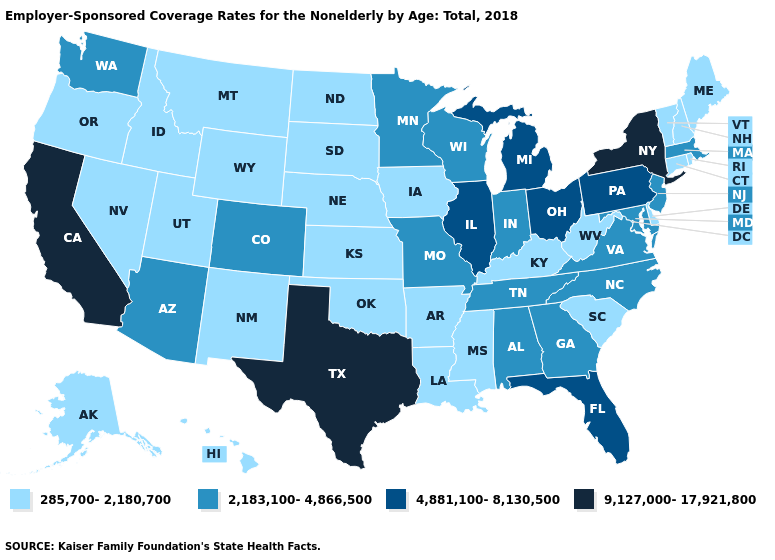Name the states that have a value in the range 4,881,100-8,130,500?
Short answer required. Florida, Illinois, Michigan, Ohio, Pennsylvania. What is the value of Vermont?
Short answer required. 285,700-2,180,700. Does West Virginia have the lowest value in the South?
Quick response, please. Yes. Does the first symbol in the legend represent the smallest category?
Answer briefly. Yes. What is the value of Maryland?
Concise answer only. 2,183,100-4,866,500. What is the highest value in the Northeast ?
Answer briefly. 9,127,000-17,921,800. Name the states that have a value in the range 2,183,100-4,866,500?
Give a very brief answer. Alabama, Arizona, Colorado, Georgia, Indiana, Maryland, Massachusetts, Minnesota, Missouri, New Jersey, North Carolina, Tennessee, Virginia, Washington, Wisconsin. What is the value of New Mexico?
Keep it brief. 285,700-2,180,700. What is the value of Alaska?
Quick response, please. 285,700-2,180,700. What is the highest value in the USA?
Give a very brief answer. 9,127,000-17,921,800. Which states have the highest value in the USA?
Be succinct. California, New York, Texas. What is the lowest value in the USA?
Concise answer only. 285,700-2,180,700. What is the lowest value in the USA?
Answer briefly. 285,700-2,180,700. Does Massachusetts have the lowest value in the USA?
Concise answer only. No. Which states hav the highest value in the South?
Be succinct. Texas. 